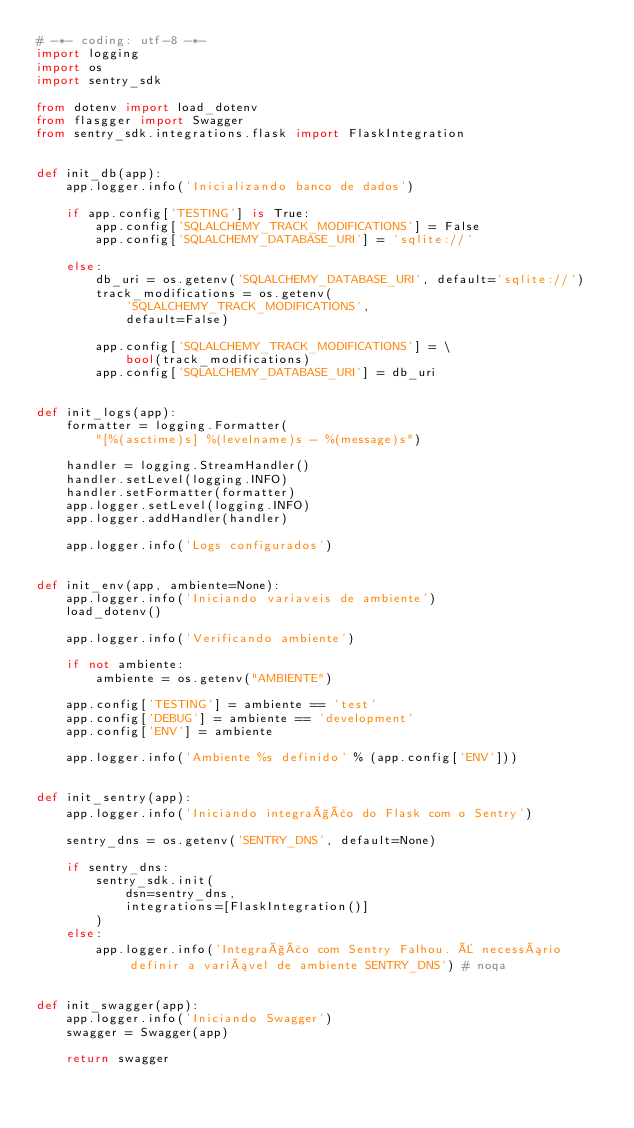Convert code to text. <code><loc_0><loc_0><loc_500><loc_500><_Python_># -*- coding: utf-8 -*-
import logging
import os
import sentry_sdk

from dotenv import load_dotenv
from flasgger import Swagger
from sentry_sdk.integrations.flask import FlaskIntegration


def init_db(app):
    app.logger.info('Inicializando banco de dados')

    if app.config['TESTING'] is True:
        app.config['SQLALCHEMY_TRACK_MODIFICATIONS'] = False
        app.config['SQLALCHEMY_DATABASE_URI'] = 'sqlite://'

    else:
        db_uri = os.getenv('SQLALCHEMY_DATABASE_URI', default='sqlite://')
        track_modifications = os.getenv(
            'SQLALCHEMY_TRACK_MODIFICATIONS',
            default=False)

        app.config['SQLALCHEMY_TRACK_MODIFICATIONS'] = \
            bool(track_modifications)
        app.config['SQLALCHEMY_DATABASE_URI'] = db_uri


def init_logs(app):
    formatter = logging.Formatter(
        "[%(asctime)s] %(levelname)s - %(message)s")

    handler = logging.StreamHandler()
    handler.setLevel(logging.INFO)
    handler.setFormatter(formatter)
    app.logger.setLevel(logging.INFO)
    app.logger.addHandler(handler)

    app.logger.info('Logs configurados')


def init_env(app, ambiente=None):
    app.logger.info('Iniciando variaveis de ambiente')
    load_dotenv()

    app.logger.info('Verificando ambiente')

    if not ambiente:
        ambiente = os.getenv("AMBIENTE")

    app.config['TESTING'] = ambiente == 'test'
    app.config['DEBUG'] = ambiente == 'development'
    app.config['ENV'] = ambiente

    app.logger.info('Ambiente %s definido' % (app.config['ENV']))


def init_sentry(app):
    app.logger.info('Iniciando integração do Flask com o Sentry')

    sentry_dns = os.getenv('SENTRY_DNS', default=None)

    if sentry_dns:
        sentry_sdk.init(
            dsn=sentry_dns,
            integrations=[FlaskIntegration()]
        )
    else:
        app.logger.info('Integração com Sentry Falhou. É necessário definir a variável de ambiente SENTRY_DNS') # noqa


def init_swagger(app):
    app.logger.info('Iniciando Swagger')
    swagger = Swagger(app)

    return swagger
</code> 